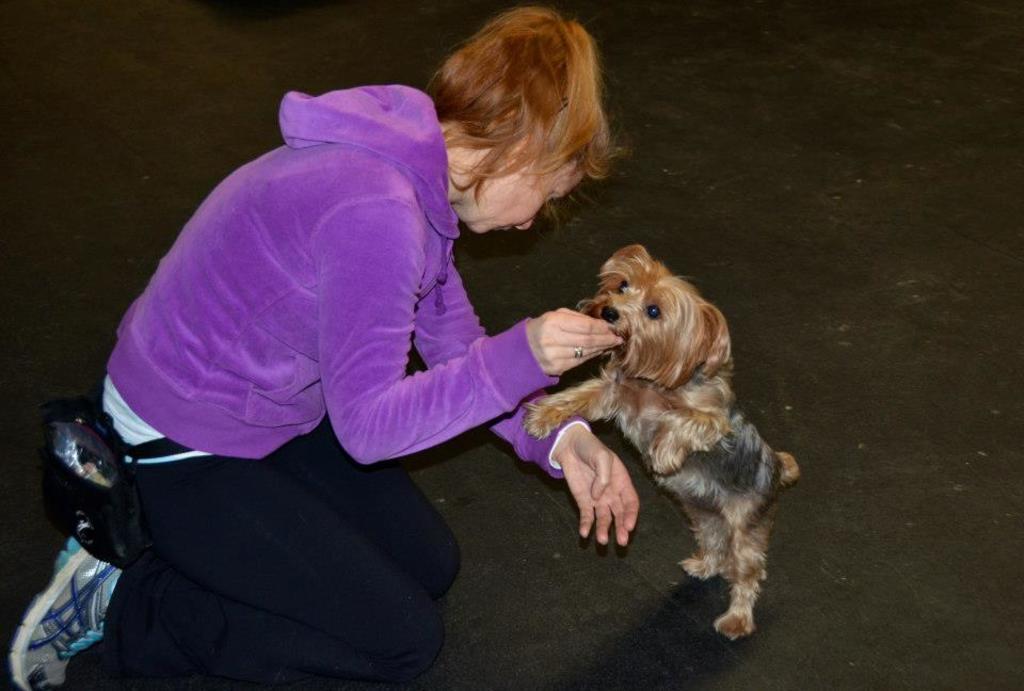Describe this image in one or two sentences. In this picture we can see a woman and she is playing with a dog. 